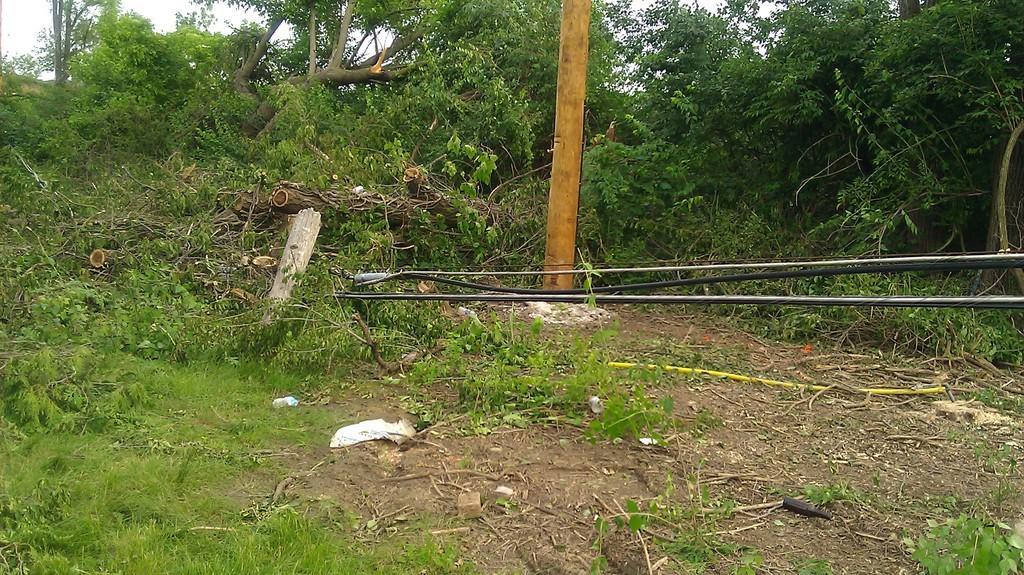Describe this image in one or two sentences. In this image I can see there are trees. In the middle there is an object in gold color. In the middle there are pipes in black and stainless steel color. 